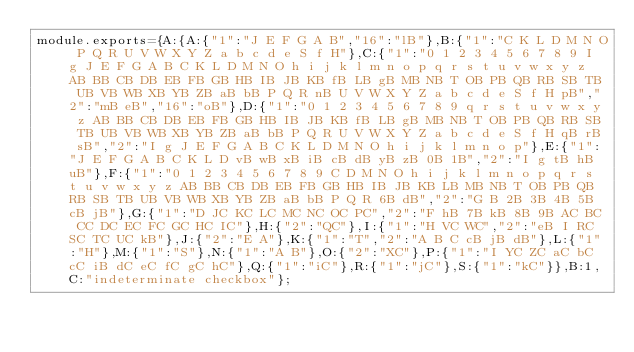<code> <loc_0><loc_0><loc_500><loc_500><_JavaScript_>module.exports={A:{A:{"1":"J E F G A B","16":"lB"},B:{"1":"C K L D M N O P Q R U V W X Y Z a b c d e S f H"},C:{"1":"0 1 2 3 4 5 6 7 8 9 I g J E F G A B C K L D M N O h i j k l m n o p q r s t u v w x y z AB BB CB DB EB FB GB HB IB JB KB fB LB gB MB NB T OB PB QB RB SB TB UB VB WB XB YB ZB aB bB P Q R nB U V W X Y Z a b c d e S f H pB","2":"mB eB","16":"oB"},D:{"1":"0 1 2 3 4 5 6 7 8 9 q r s t u v w x y z AB BB CB DB EB FB GB HB IB JB KB fB LB gB MB NB T OB PB QB RB SB TB UB VB WB XB YB ZB aB bB P Q R U V W X Y Z a b c d e S f H qB rB sB","2":"I g J E F G A B C K L D M N O h i j k l m n o p"},E:{"1":"J E F G A B C K L D vB wB xB iB cB dB yB zB 0B 1B","2":"I g tB hB uB"},F:{"1":"0 1 2 3 4 5 6 7 8 9 C D M N O h i j k l m n o p q r s t u v w x y z AB BB CB DB EB FB GB HB IB JB KB LB MB NB T OB PB QB RB SB TB UB VB WB XB YB ZB aB bB P Q R 6B dB","2":"G B 2B 3B 4B 5B cB jB"},G:{"1":"D JC KC LC MC NC OC PC","2":"F hB 7B kB 8B 9B AC BC CC DC EC FC GC HC IC"},H:{"2":"QC"},I:{"1":"H VC WC","2":"eB I RC SC TC UC kB"},J:{"2":"E A"},K:{"1":"T","2":"A B C cB jB dB"},L:{"1":"H"},M:{"1":"S"},N:{"1":"A B"},O:{"2":"XC"},P:{"1":"I YC ZC aC bC cC iB dC eC fC gC hC"},Q:{"1":"iC"},R:{"1":"jC"},S:{"1":"kC"}},B:1,C:"indeterminate checkbox"};
</code> 